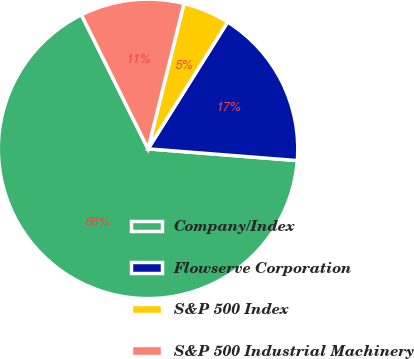<chart> <loc_0><loc_0><loc_500><loc_500><pie_chart><fcel>Company/Index<fcel>Flowserve Corporation<fcel>S&P 500 Index<fcel>S&P 500 Industrial Machinery<nl><fcel>66.4%<fcel>17.33%<fcel>5.06%<fcel>11.2%<nl></chart> 